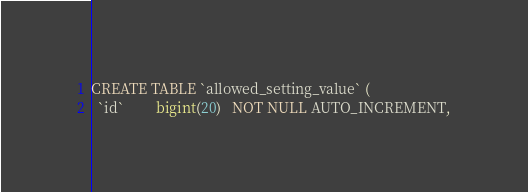Convert code to text. <code><loc_0><loc_0><loc_500><loc_500><_SQL_>CREATE TABLE `allowed_setting_value` (
  `id`         bigint(20)   NOT NULL AUTO_INCREMENT,</code> 